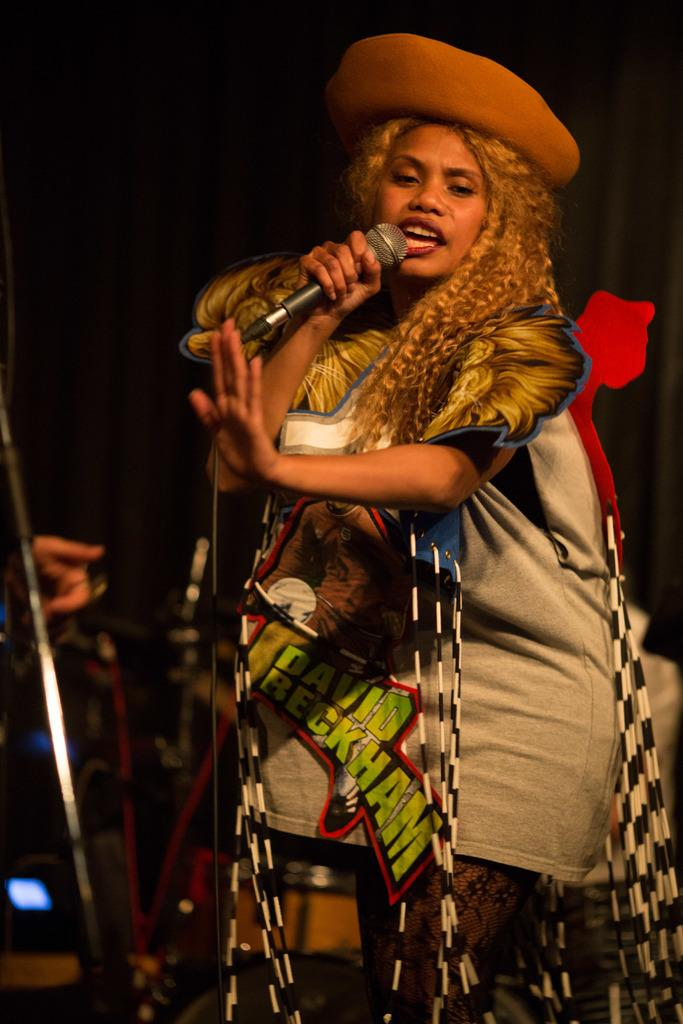Who is the main subject in the picture? A: There is a woman in the picture. What is the woman doing with the microphone? The woman is catching a microphone. What activity is the woman engaged in? The woman is singing. How many passengers are in the car with the woman in the image? There is no car present in the image, so it is not possible to determine the number of passengers. 